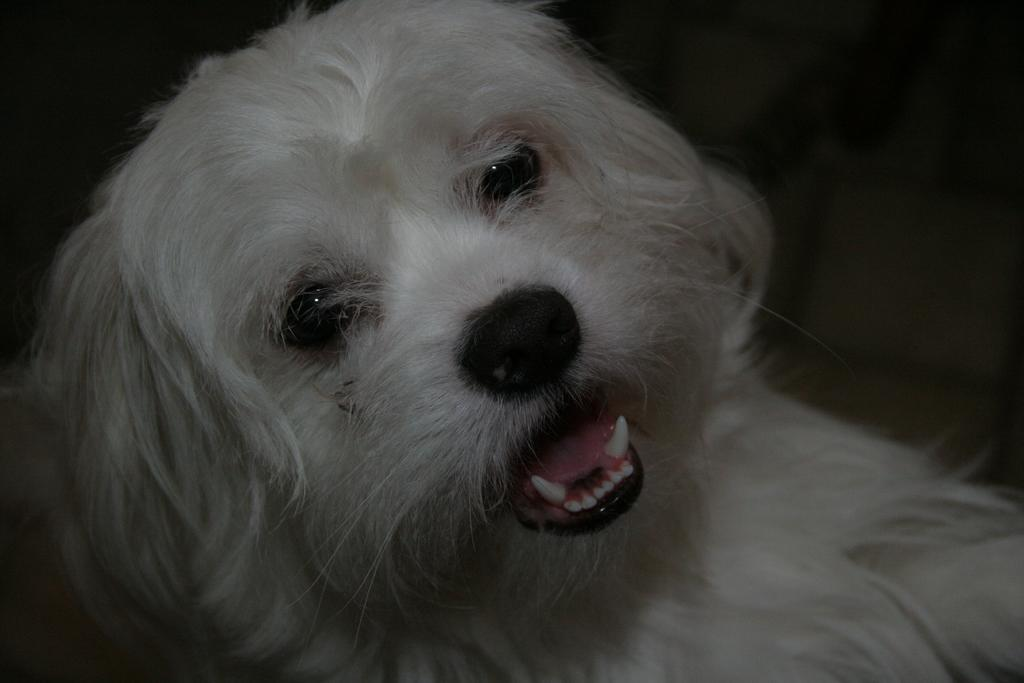What type of animal is in the image? There is a white dog in the image. Can you describe the background of the image? The background of the dog is blurred. What type of help can be seen in the image? There is no help visible in the image; it only features a white dog with a blurred background. 